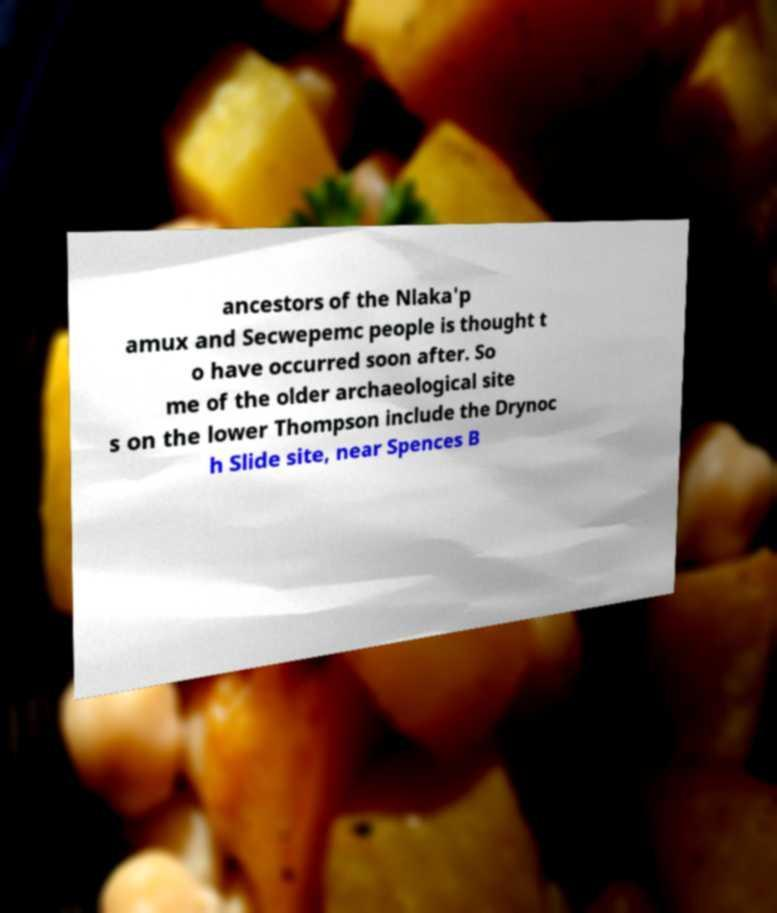For documentation purposes, I need the text within this image transcribed. Could you provide that? ancestors of the Nlaka'p amux and Secwepemc people is thought t o have occurred soon after. So me of the older archaeological site s on the lower Thompson include the Drynoc h Slide site, near Spences B 